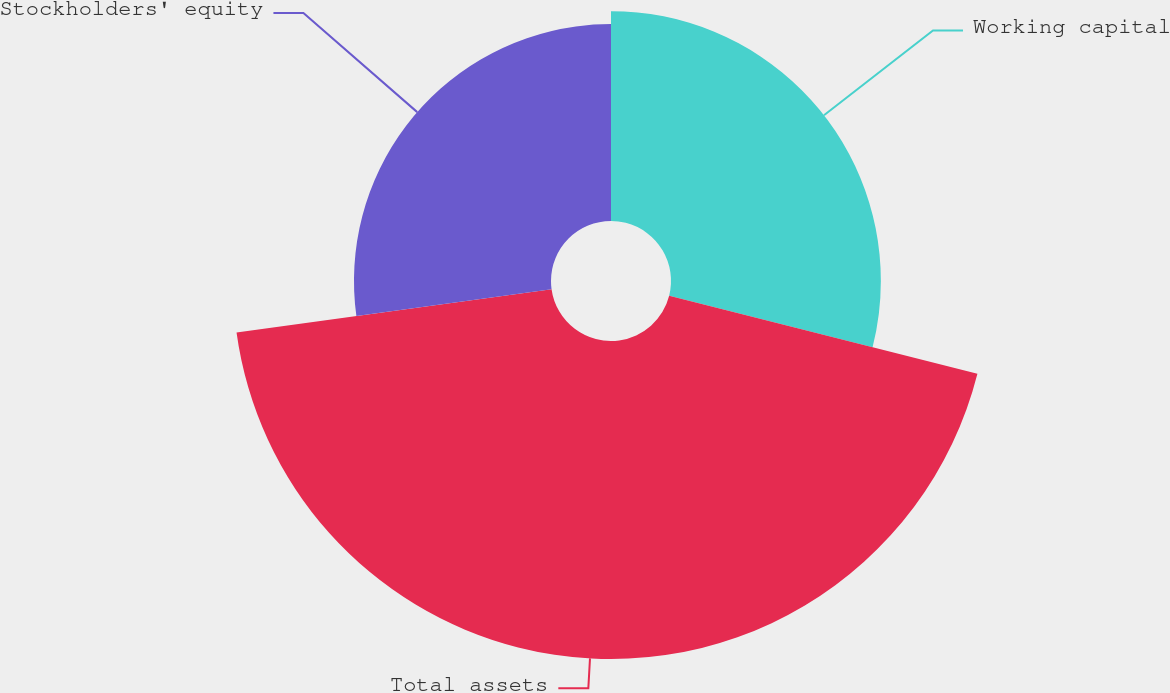<chart> <loc_0><loc_0><loc_500><loc_500><pie_chart><fcel>Working capital<fcel>Total assets<fcel>Stockholders' equity<nl><fcel>28.95%<fcel>43.87%<fcel>27.18%<nl></chart> 